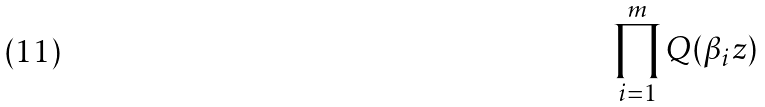Convert formula to latex. <formula><loc_0><loc_0><loc_500><loc_500>\prod _ { i = 1 } ^ { m } Q ( \beta _ { i } z )</formula> 